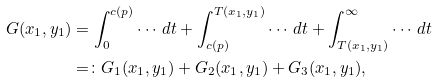Convert formula to latex. <formula><loc_0><loc_0><loc_500><loc_500>G ( x _ { 1 } , y _ { 1 } ) & = \int _ { 0 } ^ { c ( p ) } \cdots \, d t + \int _ { c ( p ) } ^ { T ( x _ { 1 } , y _ { 1 } ) } \cdots \, d t + \int _ { T ( x _ { 1 } , y _ { 1 } ) } ^ { \infty } \cdots \, d t \\ & = \colon G _ { 1 } ( x _ { 1 } , y _ { 1 } ) + G _ { 2 } ( x _ { 1 } , y _ { 1 } ) + G _ { 3 } ( x _ { 1 } , y _ { 1 } ) ,</formula> 